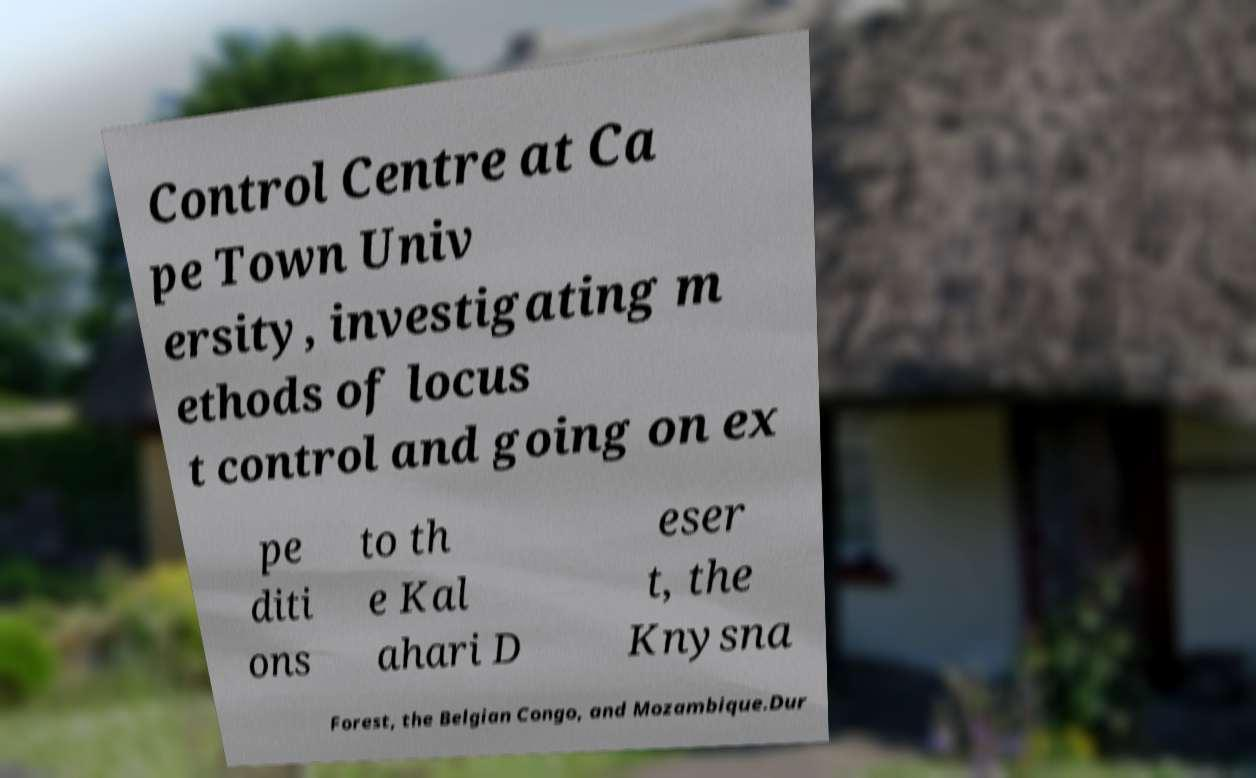Could you assist in decoding the text presented in this image and type it out clearly? Control Centre at Ca pe Town Univ ersity, investigating m ethods of locus t control and going on ex pe diti ons to th e Kal ahari D eser t, the Knysna Forest, the Belgian Congo, and Mozambique.Dur 